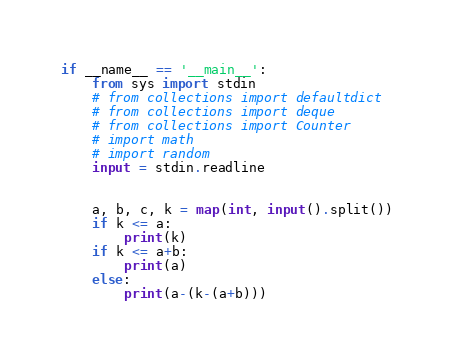<code> <loc_0><loc_0><loc_500><loc_500><_Python_>if __name__ == '__main__':
    from sys import stdin
    # from collections import defaultdict
    # from collections import deque
    # from collections import Counter
    # import math
    # import random
    input = stdin.readline


    a, b, c, k = map(int, input().split())
    if k <= a:
        print(k)
    if k <= a+b:
        print(a)
    else:
        print(a-(k-(a+b)))</code> 